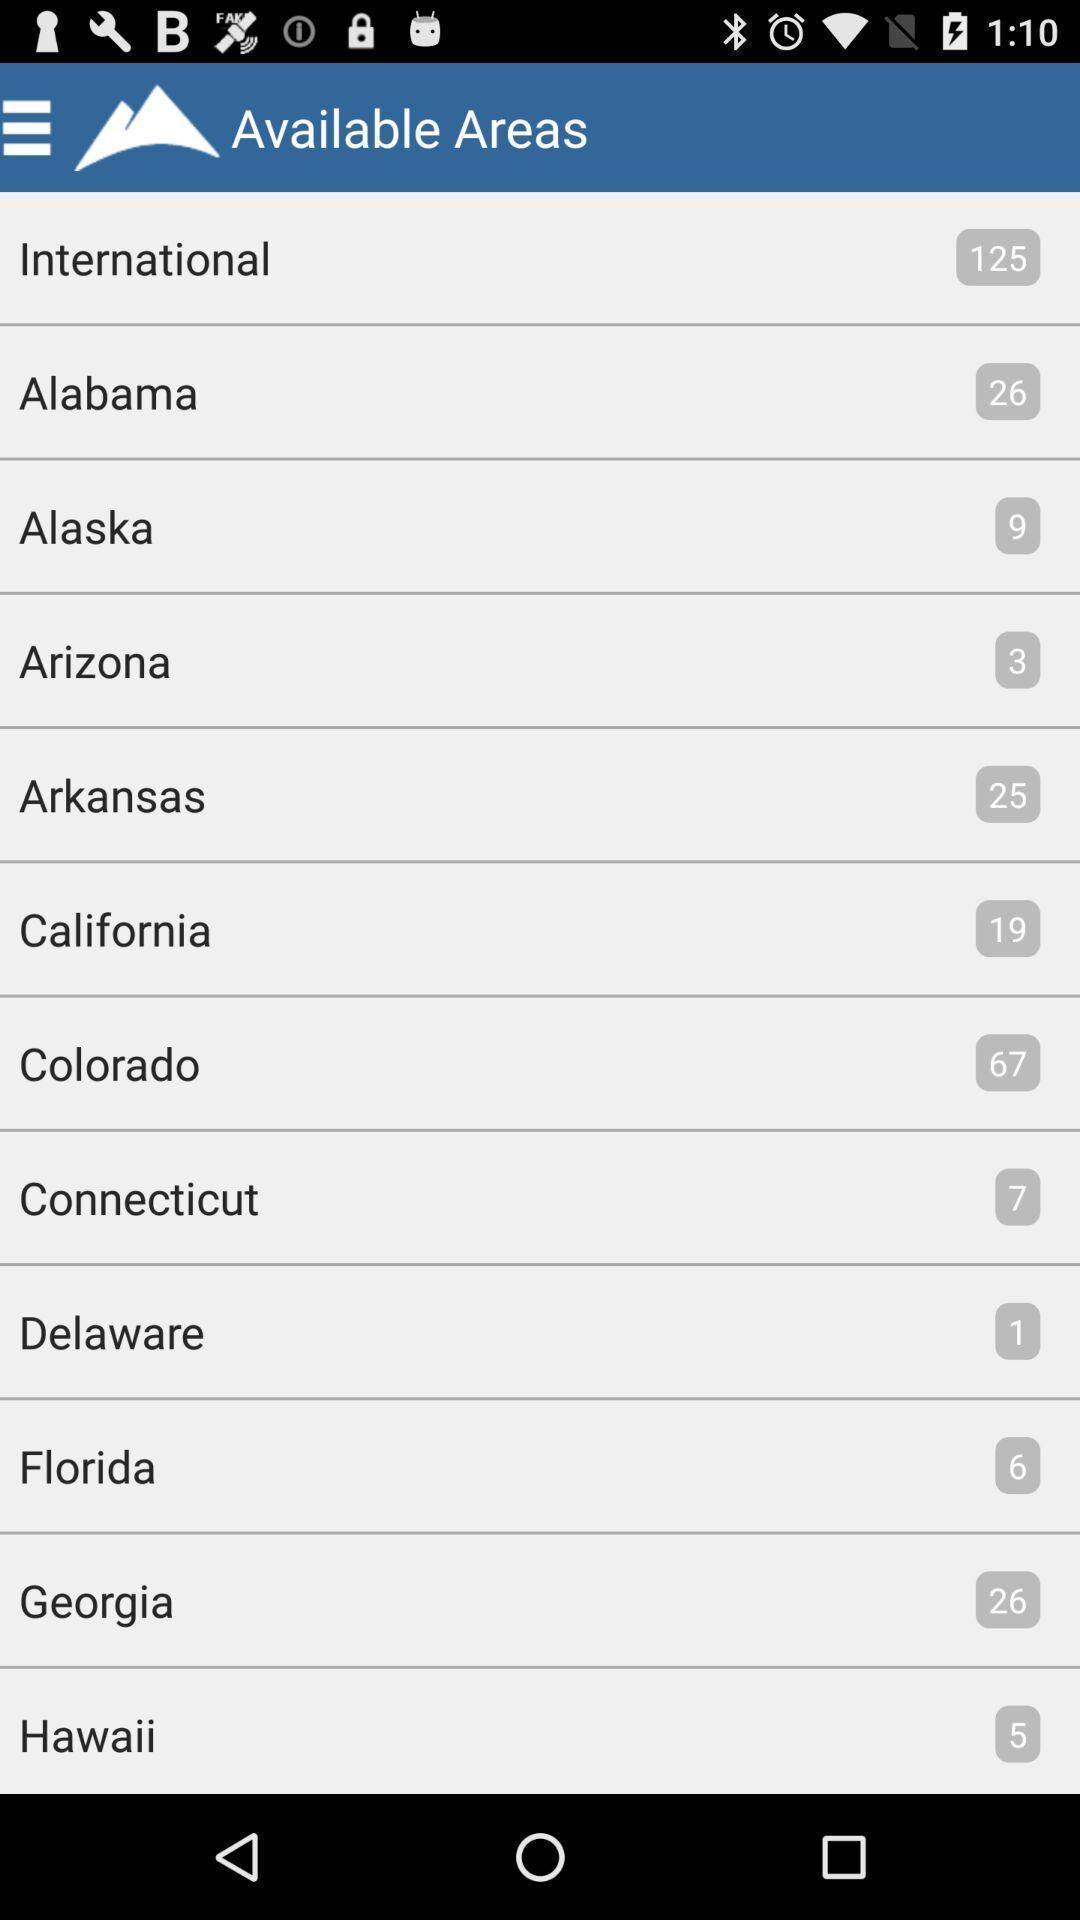Please provide a description for this image. Page showing available areas. 